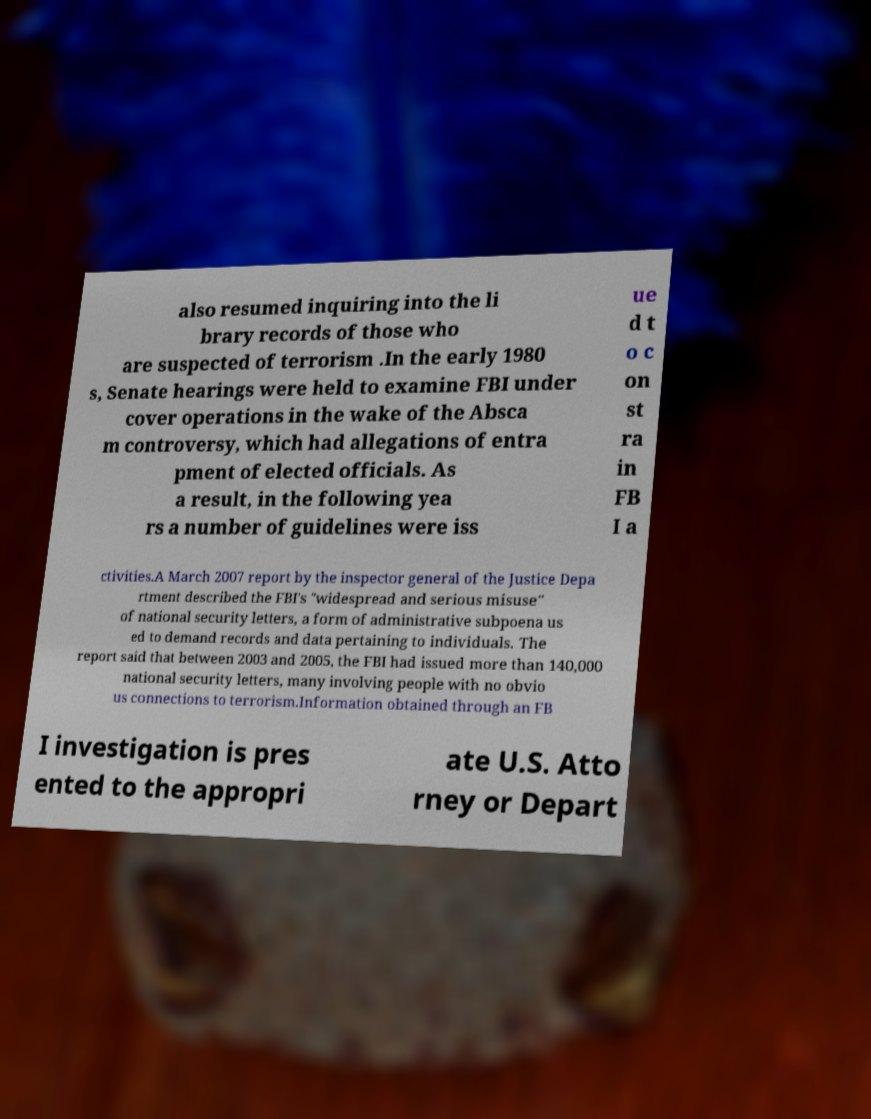Can you accurately transcribe the text from the provided image for me? also resumed inquiring into the li brary records of those who are suspected of terrorism .In the early 1980 s, Senate hearings were held to examine FBI under cover operations in the wake of the Absca m controversy, which had allegations of entra pment of elected officials. As a result, in the following yea rs a number of guidelines were iss ue d t o c on st ra in FB I a ctivities.A March 2007 report by the inspector general of the Justice Depa rtment described the FBI's "widespread and serious misuse" of national security letters, a form of administrative subpoena us ed to demand records and data pertaining to individuals. The report said that between 2003 and 2005, the FBI had issued more than 140,000 national security letters, many involving people with no obvio us connections to terrorism.Information obtained through an FB I investigation is pres ented to the appropri ate U.S. Atto rney or Depart 